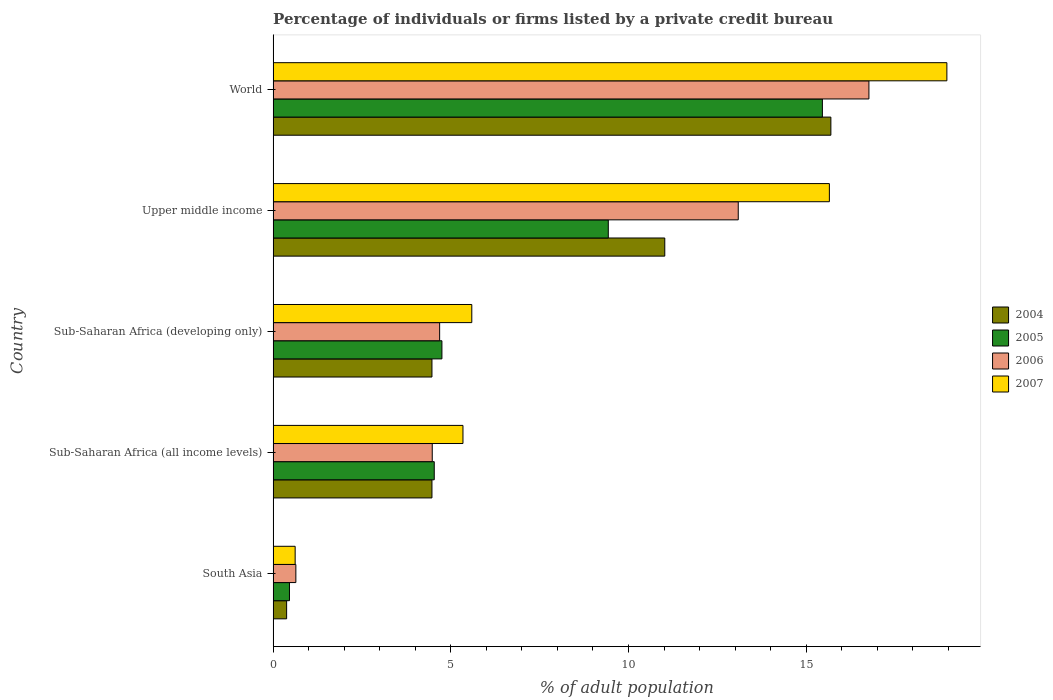How many groups of bars are there?
Offer a terse response. 5. Are the number of bars per tick equal to the number of legend labels?
Make the answer very short. Yes. Are the number of bars on each tick of the Y-axis equal?
Your answer should be compact. Yes. What is the label of the 1st group of bars from the top?
Offer a terse response. World. In how many cases, is the number of bars for a given country not equal to the number of legend labels?
Offer a terse response. 0. What is the percentage of population listed by a private credit bureau in 2006 in Sub-Saharan Africa (all income levels)?
Ensure brevity in your answer.  4.48. Across all countries, what is the maximum percentage of population listed by a private credit bureau in 2006?
Provide a succinct answer. 16.77. Across all countries, what is the minimum percentage of population listed by a private credit bureau in 2006?
Your answer should be very brief. 0.64. In which country was the percentage of population listed by a private credit bureau in 2006 maximum?
Keep it short and to the point. World. In which country was the percentage of population listed by a private credit bureau in 2005 minimum?
Your response must be concise. South Asia. What is the total percentage of population listed by a private credit bureau in 2005 in the graph?
Provide a short and direct response. 34.63. What is the difference between the percentage of population listed by a private credit bureau in 2006 in Sub-Saharan Africa (developing only) and that in World?
Your answer should be very brief. -12.08. What is the difference between the percentage of population listed by a private credit bureau in 2006 in South Asia and the percentage of population listed by a private credit bureau in 2007 in Upper middle income?
Provide a short and direct response. -15.01. What is the average percentage of population listed by a private credit bureau in 2007 per country?
Provide a succinct answer. 9.23. What is the difference between the percentage of population listed by a private credit bureau in 2007 and percentage of population listed by a private credit bureau in 2005 in Sub-Saharan Africa (all income levels)?
Ensure brevity in your answer.  0.81. In how many countries, is the percentage of population listed by a private credit bureau in 2006 greater than 3 %?
Offer a very short reply. 4. What is the ratio of the percentage of population listed by a private credit bureau in 2007 in South Asia to that in Sub-Saharan Africa (all income levels)?
Give a very brief answer. 0.12. Is the difference between the percentage of population listed by a private credit bureau in 2007 in South Asia and Upper middle income greater than the difference between the percentage of population listed by a private credit bureau in 2005 in South Asia and Upper middle income?
Offer a terse response. No. What is the difference between the highest and the second highest percentage of population listed by a private credit bureau in 2005?
Offer a terse response. 6.02. What is the difference between the highest and the lowest percentage of population listed by a private credit bureau in 2005?
Ensure brevity in your answer.  15. Is the sum of the percentage of population listed by a private credit bureau in 2004 in South Asia and Sub-Saharan Africa (developing only) greater than the maximum percentage of population listed by a private credit bureau in 2007 across all countries?
Ensure brevity in your answer.  No. Is it the case that in every country, the sum of the percentage of population listed by a private credit bureau in 2006 and percentage of population listed by a private credit bureau in 2007 is greater than the sum of percentage of population listed by a private credit bureau in 2005 and percentage of population listed by a private credit bureau in 2004?
Make the answer very short. No. What does the 1st bar from the bottom in South Asia represents?
Offer a very short reply. 2004. Is it the case that in every country, the sum of the percentage of population listed by a private credit bureau in 2005 and percentage of population listed by a private credit bureau in 2007 is greater than the percentage of population listed by a private credit bureau in 2004?
Your answer should be very brief. Yes. How many bars are there?
Your response must be concise. 20. What is the difference between two consecutive major ticks on the X-axis?
Keep it short and to the point. 5. Does the graph contain any zero values?
Provide a short and direct response. No. Where does the legend appear in the graph?
Offer a very short reply. Center right. How are the legend labels stacked?
Your answer should be compact. Vertical. What is the title of the graph?
Give a very brief answer. Percentage of individuals or firms listed by a private credit bureau. Does "1972" appear as one of the legend labels in the graph?
Make the answer very short. No. What is the label or title of the X-axis?
Offer a terse response. % of adult population. What is the label or title of the Y-axis?
Provide a short and direct response. Country. What is the % of adult population in 2004 in South Asia?
Provide a short and direct response. 0.38. What is the % of adult population of 2005 in South Asia?
Your answer should be compact. 0.46. What is the % of adult population in 2006 in South Asia?
Provide a short and direct response. 0.64. What is the % of adult population of 2007 in South Asia?
Your answer should be very brief. 0.62. What is the % of adult population of 2004 in Sub-Saharan Africa (all income levels)?
Provide a succinct answer. 4.47. What is the % of adult population in 2005 in Sub-Saharan Africa (all income levels)?
Your answer should be very brief. 4.53. What is the % of adult population of 2006 in Sub-Saharan Africa (all income levels)?
Provide a short and direct response. 4.48. What is the % of adult population in 2007 in Sub-Saharan Africa (all income levels)?
Provide a short and direct response. 5.34. What is the % of adult population of 2004 in Sub-Saharan Africa (developing only)?
Your answer should be compact. 4.47. What is the % of adult population of 2005 in Sub-Saharan Africa (developing only)?
Give a very brief answer. 4.75. What is the % of adult population of 2006 in Sub-Saharan Africa (developing only)?
Ensure brevity in your answer.  4.69. What is the % of adult population in 2007 in Sub-Saharan Africa (developing only)?
Make the answer very short. 5.59. What is the % of adult population in 2004 in Upper middle income?
Your answer should be compact. 11.02. What is the % of adult population of 2005 in Upper middle income?
Your response must be concise. 9.43. What is the % of adult population of 2006 in Upper middle income?
Provide a short and direct response. 13.09. What is the % of adult population of 2007 in Upper middle income?
Provide a short and direct response. 15.65. What is the % of adult population of 2004 in World?
Keep it short and to the point. 15.7. What is the % of adult population of 2005 in World?
Make the answer very short. 15.46. What is the % of adult population of 2006 in World?
Offer a very short reply. 16.77. What is the % of adult population of 2007 in World?
Your response must be concise. 18.96. Across all countries, what is the maximum % of adult population of 2004?
Give a very brief answer. 15.7. Across all countries, what is the maximum % of adult population of 2005?
Your answer should be very brief. 15.46. Across all countries, what is the maximum % of adult population in 2006?
Provide a short and direct response. 16.77. Across all countries, what is the maximum % of adult population of 2007?
Offer a terse response. 18.96. Across all countries, what is the minimum % of adult population in 2004?
Ensure brevity in your answer.  0.38. Across all countries, what is the minimum % of adult population of 2005?
Your response must be concise. 0.46. Across all countries, what is the minimum % of adult population of 2006?
Your answer should be compact. 0.64. Across all countries, what is the minimum % of adult population of 2007?
Give a very brief answer. 0.62. What is the total % of adult population of 2004 in the graph?
Keep it short and to the point. 36.04. What is the total % of adult population of 2005 in the graph?
Keep it short and to the point. 34.63. What is the total % of adult population in 2006 in the graph?
Your response must be concise. 39.66. What is the total % of adult population of 2007 in the graph?
Your response must be concise. 46.17. What is the difference between the % of adult population of 2004 in South Asia and that in Sub-Saharan Africa (all income levels)?
Your answer should be compact. -4.09. What is the difference between the % of adult population in 2005 in South Asia and that in Sub-Saharan Africa (all income levels)?
Ensure brevity in your answer.  -4.07. What is the difference between the % of adult population in 2006 in South Asia and that in Sub-Saharan Africa (all income levels)?
Give a very brief answer. -3.84. What is the difference between the % of adult population of 2007 in South Asia and that in Sub-Saharan Africa (all income levels)?
Give a very brief answer. -4.72. What is the difference between the % of adult population in 2004 in South Asia and that in Sub-Saharan Africa (developing only)?
Your answer should be very brief. -4.09. What is the difference between the % of adult population of 2005 in South Asia and that in Sub-Saharan Africa (developing only)?
Ensure brevity in your answer.  -4.29. What is the difference between the % of adult population in 2006 in South Asia and that in Sub-Saharan Africa (developing only)?
Provide a short and direct response. -4.05. What is the difference between the % of adult population of 2007 in South Asia and that in Sub-Saharan Africa (developing only)?
Offer a very short reply. -4.97. What is the difference between the % of adult population of 2004 in South Asia and that in Upper middle income?
Your answer should be compact. -10.64. What is the difference between the % of adult population in 2005 in South Asia and that in Upper middle income?
Your response must be concise. -8.97. What is the difference between the % of adult population of 2006 in South Asia and that in Upper middle income?
Give a very brief answer. -12.45. What is the difference between the % of adult population of 2007 in South Asia and that in Upper middle income?
Provide a short and direct response. -15.03. What is the difference between the % of adult population of 2004 in South Asia and that in World?
Offer a very short reply. -15.32. What is the difference between the % of adult population in 2005 in South Asia and that in World?
Offer a terse response. -15. What is the difference between the % of adult population in 2006 in South Asia and that in World?
Your answer should be compact. -16.13. What is the difference between the % of adult population in 2007 in South Asia and that in World?
Your response must be concise. -18.34. What is the difference between the % of adult population of 2004 in Sub-Saharan Africa (all income levels) and that in Sub-Saharan Africa (developing only)?
Your response must be concise. 0. What is the difference between the % of adult population of 2005 in Sub-Saharan Africa (all income levels) and that in Sub-Saharan Africa (developing only)?
Provide a short and direct response. -0.22. What is the difference between the % of adult population in 2006 in Sub-Saharan Africa (all income levels) and that in Sub-Saharan Africa (developing only)?
Give a very brief answer. -0.21. What is the difference between the % of adult population of 2007 in Sub-Saharan Africa (all income levels) and that in Sub-Saharan Africa (developing only)?
Offer a terse response. -0.25. What is the difference between the % of adult population of 2004 in Sub-Saharan Africa (all income levels) and that in Upper middle income?
Your answer should be very brief. -6.55. What is the difference between the % of adult population in 2005 in Sub-Saharan Africa (all income levels) and that in Upper middle income?
Your answer should be compact. -4.9. What is the difference between the % of adult population in 2006 in Sub-Saharan Africa (all income levels) and that in Upper middle income?
Your response must be concise. -8.61. What is the difference between the % of adult population of 2007 in Sub-Saharan Africa (all income levels) and that in Upper middle income?
Ensure brevity in your answer.  -10.31. What is the difference between the % of adult population of 2004 in Sub-Saharan Africa (all income levels) and that in World?
Your response must be concise. -11.23. What is the difference between the % of adult population of 2005 in Sub-Saharan Africa (all income levels) and that in World?
Make the answer very short. -10.92. What is the difference between the % of adult population of 2006 in Sub-Saharan Africa (all income levels) and that in World?
Offer a very short reply. -12.29. What is the difference between the % of adult population in 2007 in Sub-Saharan Africa (all income levels) and that in World?
Provide a succinct answer. -13.62. What is the difference between the % of adult population of 2004 in Sub-Saharan Africa (developing only) and that in Upper middle income?
Your response must be concise. -6.55. What is the difference between the % of adult population in 2005 in Sub-Saharan Africa (developing only) and that in Upper middle income?
Give a very brief answer. -4.68. What is the difference between the % of adult population of 2006 in Sub-Saharan Africa (developing only) and that in Upper middle income?
Your answer should be very brief. -8.4. What is the difference between the % of adult population in 2007 in Sub-Saharan Africa (developing only) and that in Upper middle income?
Your answer should be very brief. -10.06. What is the difference between the % of adult population in 2004 in Sub-Saharan Africa (developing only) and that in World?
Make the answer very short. -11.23. What is the difference between the % of adult population of 2005 in Sub-Saharan Africa (developing only) and that in World?
Ensure brevity in your answer.  -10.71. What is the difference between the % of adult population of 2006 in Sub-Saharan Africa (developing only) and that in World?
Give a very brief answer. -12.08. What is the difference between the % of adult population in 2007 in Sub-Saharan Africa (developing only) and that in World?
Make the answer very short. -13.37. What is the difference between the % of adult population in 2004 in Upper middle income and that in World?
Your answer should be very brief. -4.67. What is the difference between the % of adult population of 2005 in Upper middle income and that in World?
Give a very brief answer. -6.02. What is the difference between the % of adult population of 2006 in Upper middle income and that in World?
Give a very brief answer. -3.68. What is the difference between the % of adult population of 2007 in Upper middle income and that in World?
Give a very brief answer. -3.31. What is the difference between the % of adult population in 2004 in South Asia and the % of adult population in 2005 in Sub-Saharan Africa (all income levels)?
Provide a short and direct response. -4.15. What is the difference between the % of adult population of 2004 in South Asia and the % of adult population of 2006 in Sub-Saharan Africa (all income levels)?
Your response must be concise. -4.1. What is the difference between the % of adult population of 2004 in South Asia and the % of adult population of 2007 in Sub-Saharan Africa (all income levels)?
Provide a succinct answer. -4.96. What is the difference between the % of adult population in 2005 in South Asia and the % of adult population in 2006 in Sub-Saharan Africa (all income levels)?
Your answer should be very brief. -4.02. What is the difference between the % of adult population of 2005 in South Asia and the % of adult population of 2007 in Sub-Saharan Africa (all income levels)?
Give a very brief answer. -4.88. What is the difference between the % of adult population of 2006 in South Asia and the % of adult population of 2007 in Sub-Saharan Africa (all income levels)?
Keep it short and to the point. -4.7. What is the difference between the % of adult population in 2004 in South Asia and the % of adult population in 2005 in Sub-Saharan Africa (developing only)?
Your answer should be very brief. -4.37. What is the difference between the % of adult population in 2004 in South Asia and the % of adult population in 2006 in Sub-Saharan Africa (developing only)?
Make the answer very short. -4.31. What is the difference between the % of adult population in 2004 in South Asia and the % of adult population in 2007 in Sub-Saharan Africa (developing only)?
Your answer should be very brief. -5.21. What is the difference between the % of adult population of 2005 in South Asia and the % of adult population of 2006 in Sub-Saharan Africa (developing only)?
Provide a short and direct response. -4.23. What is the difference between the % of adult population in 2005 in South Asia and the % of adult population in 2007 in Sub-Saharan Africa (developing only)?
Offer a very short reply. -5.13. What is the difference between the % of adult population in 2006 in South Asia and the % of adult population in 2007 in Sub-Saharan Africa (developing only)?
Provide a short and direct response. -4.95. What is the difference between the % of adult population of 2004 in South Asia and the % of adult population of 2005 in Upper middle income?
Your answer should be compact. -9.05. What is the difference between the % of adult population in 2004 in South Asia and the % of adult population in 2006 in Upper middle income?
Give a very brief answer. -12.71. What is the difference between the % of adult population of 2004 in South Asia and the % of adult population of 2007 in Upper middle income?
Offer a very short reply. -15.27. What is the difference between the % of adult population of 2005 in South Asia and the % of adult population of 2006 in Upper middle income?
Provide a succinct answer. -12.63. What is the difference between the % of adult population of 2005 in South Asia and the % of adult population of 2007 in Upper middle income?
Your answer should be very brief. -15.19. What is the difference between the % of adult population in 2006 in South Asia and the % of adult population in 2007 in Upper middle income?
Your response must be concise. -15.01. What is the difference between the % of adult population in 2004 in South Asia and the % of adult population in 2005 in World?
Your answer should be compact. -15.08. What is the difference between the % of adult population of 2004 in South Asia and the % of adult population of 2006 in World?
Provide a succinct answer. -16.39. What is the difference between the % of adult population of 2004 in South Asia and the % of adult population of 2007 in World?
Ensure brevity in your answer.  -18.58. What is the difference between the % of adult population in 2005 in South Asia and the % of adult population in 2006 in World?
Offer a very short reply. -16.31. What is the difference between the % of adult population in 2005 in South Asia and the % of adult population in 2007 in World?
Your response must be concise. -18.5. What is the difference between the % of adult population of 2006 in South Asia and the % of adult population of 2007 in World?
Offer a very short reply. -18.32. What is the difference between the % of adult population of 2004 in Sub-Saharan Africa (all income levels) and the % of adult population of 2005 in Sub-Saharan Africa (developing only)?
Ensure brevity in your answer.  -0.28. What is the difference between the % of adult population in 2004 in Sub-Saharan Africa (all income levels) and the % of adult population in 2006 in Sub-Saharan Africa (developing only)?
Give a very brief answer. -0.22. What is the difference between the % of adult population of 2004 in Sub-Saharan Africa (all income levels) and the % of adult population of 2007 in Sub-Saharan Africa (developing only)?
Your answer should be compact. -1.12. What is the difference between the % of adult population of 2005 in Sub-Saharan Africa (all income levels) and the % of adult population of 2006 in Sub-Saharan Africa (developing only)?
Offer a terse response. -0.15. What is the difference between the % of adult population in 2005 in Sub-Saharan Africa (all income levels) and the % of adult population in 2007 in Sub-Saharan Africa (developing only)?
Make the answer very short. -1.06. What is the difference between the % of adult population in 2006 in Sub-Saharan Africa (all income levels) and the % of adult population in 2007 in Sub-Saharan Africa (developing only)?
Provide a succinct answer. -1.11. What is the difference between the % of adult population of 2004 in Sub-Saharan Africa (all income levels) and the % of adult population of 2005 in Upper middle income?
Provide a short and direct response. -4.96. What is the difference between the % of adult population in 2004 in Sub-Saharan Africa (all income levels) and the % of adult population in 2006 in Upper middle income?
Keep it short and to the point. -8.62. What is the difference between the % of adult population in 2004 in Sub-Saharan Africa (all income levels) and the % of adult population in 2007 in Upper middle income?
Provide a short and direct response. -11.18. What is the difference between the % of adult population in 2005 in Sub-Saharan Africa (all income levels) and the % of adult population in 2006 in Upper middle income?
Give a very brief answer. -8.55. What is the difference between the % of adult population in 2005 in Sub-Saharan Africa (all income levels) and the % of adult population in 2007 in Upper middle income?
Give a very brief answer. -11.12. What is the difference between the % of adult population of 2006 in Sub-Saharan Africa (all income levels) and the % of adult population of 2007 in Upper middle income?
Your response must be concise. -11.18. What is the difference between the % of adult population of 2004 in Sub-Saharan Africa (all income levels) and the % of adult population of 2005 in World?
Your response must be concise. -10.99. What is the difference between the % of adult population in 2004 in Sub-Saharan Africa (all income levels) and the % of adult population in 2006 in World?
Provide a succinct answer. -12.3. What is the difference between the % of adult population of 2004 in Sub-Saharan Africa (all income levels) and the % of adult population of 2007 in World?
Offer a terse response. -14.49. What is the difference between the % of adult population in 2005 in Sub-Saharan Africa (all income levels) and the % of adult population in 2006 in World?
Give a very brief answer. -12.23. What is the difference between the % of adult population in 2005 in Sub-Saharan Africa (all income levels) and the % of adult population in 2007 in World?
Give a very brief answer. -14.43. What is the difference between the % of adult population in 2006 in Sub-Saharan Africa (all income levels) and the % of adult population in 2007 in World?
Offer a terse response. -14.48. What is the difference between the % of adult population of 2004 in Sub-Saharan Africa (developing only) and the % of adult population of 2005 in Upper middle income?
Offer a terse response. -4.96. What is the difference between the % of adult population in 2004 in Sub-Saharan Africa (developing only) and the % of adult population in 2006 in Upper middle income?
Your response must be concise. -8.62. What is the difference between the % of adult population in 2004 in Sub-Saharan Africa (developing only) and the % of adult population in 2007 in Upper middle income?
Provide a succinct answer. -11.18. What is the difference between the % of adult population of 2005 in Sub-Saharan Africa (developing only) and the % of adult population of 2006 in Upper middle income?
Offer a very short reply. -8.34. What is the difference between the % of adult population of 2005 in Sub-Saharan Africa (developing only) and the % of adult population of 2007 in Upper middle income?
Keep it short and to the point. -10.9. What is the difference between the % of adult population of 2006 in Sub-Saharan Africa (developing only) and the % of adult population of 2007 in Upper middle income?
Your answer should be very brief. -10.97. What is the difference between the % of adult population of 2004 in Sub-Saharan Africa (developing only) and the % of adult population of 2005 in World?
Your response must be concise. -10.99. What is the difference between the % of adult population of 2004 in Sub-Saharan Africa (developing only) and the % of adult population of 2006 in World?
Your answer should be compact. -12.3. What is the difference between the % of adult population in 2004 in Sub-Saharan Africa (developing only) and the % of adult population in 2007 in World?
Your answer should be compact. -14.49. What is the difference between the % of adult population of 2005 in Sub-Saharan Africa (developing only) and the % of adult population of 2006 in World?
Your response must be concise. -12.02. What is the difference between the % of adult population in 2005 in Sub-Saharan Africa (developing only) and the % of adult population in 2007 in World?
Offer a terse response. -14.21. What is the difference between the % of adult population of 2006 in Sub-Saharan Africa (developing only) and the % of adult population of 2007 in World?
Provide a succinct answer. -14.27. What is the difference between the % of adult population of 2004 in Upper middle income and the % of adult population of 2005 in World?
Your answer should be very brief. -4.43. What is the difference between the % of adult population in 2004 in Upper middle income and the % of adult population in 2006 in World?
Offer a very short reply. -5.74. What is the difference between the % of adult population of 2004 in Upper middle income and the % of adult population of 2007 in World?
Keep it short and to the point. -7.94. What is the difference between the % of adult population in 2005 in Upper middle income and the % of adult population in 2006 in World?
Ensure brevity in your answer.  -7.33. What is the difference between the % of adult population in 2005 in Upper middle income and the % of adult population in 2007 in World?
Give a very brief answer. -9.53. What is the difference between the % of adult population of 2006 in Upper middle income and the % of adult population of 2007 in World?
Offer a terse response. -5.87. What is the average % of adult population of 2004 per country?
Your response must be concise. 7.21. What is the average % of adult population of 2005 per country?
Offer a very short reply. 6.93. What is the average % of adult population of 2006 per country?
Provide a succinct answer. 7.93. What is the average % of adult population in 2007 per country?
Provide a short and direct response. 9.23. What is the difference between the % of adult population in 2004 and % of adult population in 2005 in South Asia?
Make the answer very short. -0.08. What is the difference between the % of adult population in 2004 and % of adult population in 2006 in South Asia?
Offer a terse response. -0.26. What is the difference between the % of adult population of 2004 and % of adult population of 2007 in South Asia?
Your answer should be compact. -0.24. What is the difference between the % of adult population of 2005 and % of adult population of 2006 in South Asia?
Your answer should be compact. -0.18. What is the difference between the % of adult population in 2005 and % of adult population in 2007 in South Asia?
Your answer should be compact. -0.16. What is the difference between the % of adult population in 2004 and % of adult population in 2005 in Sub-Saharan Africa (all income levels)?
Give a very brief answer. -0.06. What is the difference between the % of adult population of 2004 and % of adult population of 2006 in Sub-Saharan Africa (all income levels)?
Offer a very short reply. -0.01. What is the difference between the % of adult population of 2004 and % of adult population of 2007 in Sub-Saharan Africa (all income levels)?
Ensure brevity in your answer.  -0.87. What is the difference between the % of adult population in 2005 and % of adult population in 2006 in Sub-Saharan Africa (all income levels)?
Your response must be concise. 0.06. What is the difference between the % of adult population in 2005 and % of adult population in 2007 in Sub-Saharan Africa (all income levels)?
Offer a very short reply. -0.81. What is the difference between the % of adult population of 2006 and % of adult population of 2007 in Sub-Saharan Africa (all income levels)?
Provide a short and direct response. -0.86. What is the difference between the % of adult population in 2004 and % of adult population in 2005 in Sub-Saharan Africa (developing only)?
Make the answer very short. -0.28. What is the difference between the % of adult population of 2004 and % of adult population of 2006 in Sub-Saharan Africa (developing only)?
Offer a very short reply. -0.22. What is the difference between the % of adult population of 2004 and % of adult population of 2007 in Sub-Saharan Africa (developing only)?
Make the answer very short. -1.12. What is the difference between the % of adult population in 2005 and % of adult population in 2006 in Sub-Saharan Africa (developing only)?
Provide a short and direct response. 0.06. What is the difference between the % of adult population in 2005 and % of adult population in 2007 in Sub-Saharan Africa (developing only)?
Provide a succinct answer. -0.84. What is the difference between the % of adult population of 2006 and % of adult population of 2007 in Sub-Saharan Africa (developing only)?
Your response must be concise. -0.9. What is the difference between the % of adult population of 2004 and % of adult population of 2005 in Upper middle income?
Ensure brevity in your answer.  1.59. What is the difference between the % of adult population in 2004 and % of adult population in 2006 in Upper middle income?
Offer a very short reply. -2.07. What is the difference between the % of adult population in 2004 and % of adult population in 2007 in Upper middle income?
Provide a succinct answer. -4.63. What is the difference between the % of adult population of 2005 and % of adult population of 2006 in Upper middle income?
Your answer should be compact. -3.66. What is the difference between the % of adult population in 2005 and % of adult population in 2007 in Upper middle income?
Your response must be concise. -6.22. What is the difference between the % of adult population of 2006 and % of adult population of 2007 in Upper middle income?
Offer a terse response. -2.56. What is the difference between the % of adult population in 2004 and % of adult population in 2005 in World?
Keep it short and to the point. 0.24. What is the difference between the % of adult population of 2004 and % of adult population of 2006 in World?
Ensure brevity in your answer.  -1.07. What is the difference between the % of adult population in 2004 and % of adult population in 2007 in World?
Your answer should be compact. -3.26. What is the difference between the % of adult population in 2005 and % of adult population in 2006 in World?
Ensure brevity in your answer.  -1.31. What is the difference between the % of adult population of 2005 and % of adult population of 2007 in World?
Keep it short and to the point. -3.5. What is the difference between the % of adult population in 2006 and % of adult population in 2007 in World?
Your answer should be very brief. -2.19. What is the ratio of the % of adult population of 2004 in South Asia to that in Sub-Saharan Africa (all income levels)?
Make the answer very short. 0.09. What is the ratio of the % of adult population in 2005 in South Asia to that in Sub-Saharan Africa (all income levels)?
Keep it short and to the point. 0.1. What is the ratio of the % of adult population of 2006 in South Asia to that in Sub-Saharan Africa (all income levels)?
Give a very brief answer. 0.14. What is the ratio of the % of adult population in 2007 in South Asia to that in Sub-Saharan Africa (all income levels)?
Give a very brief answer. 0.12. What is the ratio of the % of adult population in 2004 in South Asia to that in Sub-Saharan Africa (developing only)?
Offer a terse response. 0.09. What is the ratio of the % of adult population in 2005 in South Asia to that in Sub-Saharan Africa (developing only)?
Your answer should be very brief. 0.1. What is the ratio of the % of adult population of 2006 in South Asia to that in Sub-Saharan Africa (developing only)?
Ensure brevity in your answer.  0.14. What is the ratio of the % of adult population of 2007 in South Asia to that in Sub-Saharan Africa (developing only)?
Offer a terse response. 0.11. What is the ratio of the % of adult population of 2004 in South Asia to that in Upper middle income?
Make the answer very short. 0.03. What is the ratio of the % of adult population of 2005 in South Asia to that in Upper middle income?
Your answer should be compact. 0.05. What is the ratio of the % of adult population in 2006 in South Asia to that in Upper middle income?
Your response must be concise. 0.05. What is the ratio of the % of adult population of 2007 in South Asia to that in Upper middle income?
Provide a short and direct response. 0.04. What is the ratio of the % of adult population of 2004 in South Asia to that in World?
Offer a terse response. 0.02. What is the ratio of the % of adult population of 2005 in South Asia to that in World?
Give a very brief answer. 0.03. What is the ratio of the % of adult population of 2006 in South Asia to that in World?
Keep it short and to the point. 0.04. What is the ratio of the % of adult population in 2007 in South Asia to that in World?
Provide a short and direct response. 0.03. What is the ratio of the % of adult population of 2004 in Sub-Saharan Africa (all income levels) to that in Sub-Saharan Africa (developing only)?
Provide a succinct answer. 1. What is the ratio of the % of adult population in 2005 in Sub-Saharan Africa (all income levels) to that in Sub-Saharan Africa (developing only)?
Provide a short and direct response. 0.95. What is the ratio of the % of adult population of 2006 in Sub-Saharan Africa (all income levels) to that in Sub-Saharan Africa (developing only)?
Provide a short and direct response. 0.96. What is the ratio of the % of adult population of 2007 in Sub-Saharan Africa (all income levels) to that in Sub-Saharan Africa (developing only)?
Keep it short and to the point. 0.96. What is the ratio of the % of adult population of 2004 in Sub-Saharan Africa (all income levels) to that in Upper middle income?
Keep it short and to the point. 0.41. What is the ratio of the % of adult population in 2005 in Sub-Saharan Africa (all income levels) to that in Upper middle income?
Make the answer very short. 0.48. What is the ratio of the % of adult population in 2006 in Sub-Saharan Africa (all income levels) to that in Upper middle income?
Keep it short and to the point. 0.34. What is the ratio of the % of adult population of 2007 in Sub-Saharan Africa (all income levels) to that in Upper middle income?
Provide a short and direct response. 0.34. What is the ratio of the % of adult population of 2004 in Sub-Saharan Africa (all income levels) to that in World?
Offer a very short reply. 0.28. What is the ratio of the % of adult population in 2005 in Sub-Saharan Africa (all income levels) to that in World?
Provide a short and direct response. 0.29. What is the ratio of the % of adult population of 2006 in Sub-Saharan Africa (all income levels) to that in World?
Your answer should be compact. 0.27. What is the ratio of the % of adult population in 2007 in Sub-Saharan Africa (all income levels) to that in World?
Make the answer very short. 0.28. What is the ratio of the % of adult population in 2004 in Sub-Saharan Africa (developing only) to that in Upper middle income?
Offer a very short reply. 0.41. What is the ratio of the % of adult population of 2005 in Sub-Saharan Africa (developing only) to that in Upper middle income?
Offer a terse response. 0.5. What is the ratio of the % of adult population in 2006 in Sub-Saharan Africa (developing only) to that in Upper middle income?
Ensure brevity in your answer.  0.36. What is the ratio of the % of adult population in 2007 in Sub-Saharan Africa (developing only) to that in Upper middle income?
Your response must be concise. 0.36. What is the ratio of the % of adult population in 2004 in Sub-Saharan Africa (developing only) to that in World?
Make the answer very short. 0.28. What is the ratio of the % of adult population in 2005 in Sub-Saharan Africa (developing only) to that in World?
Offer a very short reply. 0.31. What is the ratio of the % of adult population in 2006 in Sub-Saharan Africa (developing only) to that in World?
Provide a short and direct response. 0.28. What is the ratio of the % of adult population in 2007 in Sub-Saharan Africa (developing only) to that in World?
Your response must be concise. 0.29. What is the ratio of the % of adult population of 2004 in Upper middle income to that in World?
Give a very brief answer. 0.7. What is the ratio of the % of adult population in 2005 in Upper middle income to that in World?
Provide a short and direct response. 0.61. What is the ratio of the % of adult population in 2006 in Upper middle income to that in World?
Your answer should be very brief. 0.78. What is the ratio of the % of adult population in 2007 in Upper middle income to that in World?
Offer a very short reply. 0.83. What is the difference between the highest and the second highest % of adult population of 2004?
Your answer should be compact. 4.67. What is the difference between the highest and the second highest % of adult population of 2005?
Make the answer very short. 6.02. What is the difference between the highest and the second highest % of adult population in 2006?
Your response must be concise. 3.68. What is the difference between the highest and the second highest % of adult population of 2007?
Ensure brevity in your answer.  3.31. What is the difference between the highest and the lowest % of adult population of 2004?
Provide a short and direct response. 15.32. What is the difference between the highest and the lowest % of adult population of 2005?
Provide a short and direct response. 15. What is the difference between the highest and the lowest % of adult population in 2006?
Keep it short and to the point. 16.13. What is the difference between the highest and the lowest % of adult population of 2007?
Your answer should be compact. 18.34. 